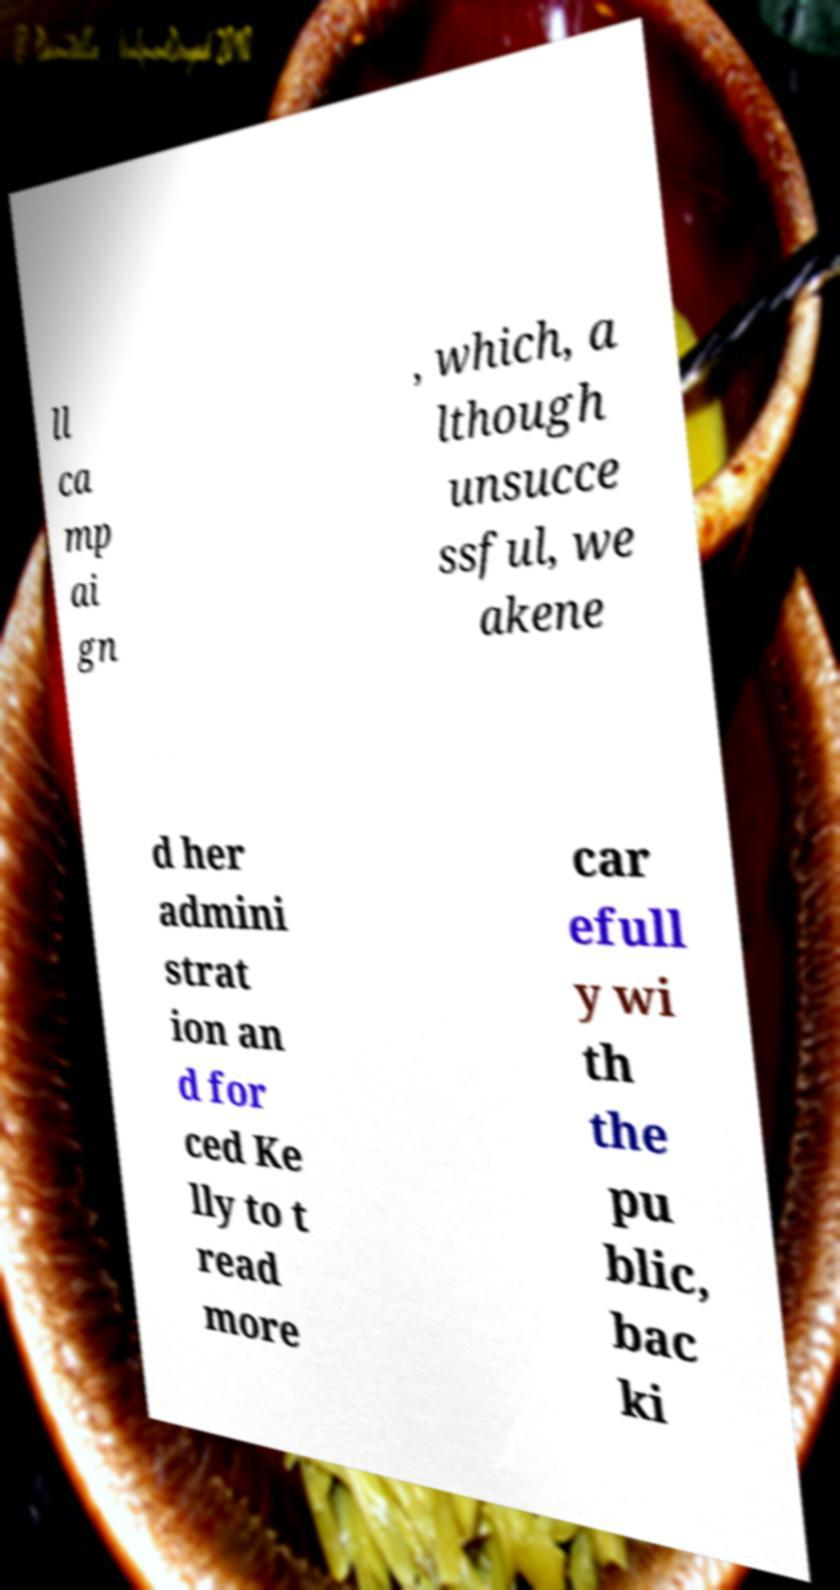What messages or text are displayed in this image? I need them in a readable, typed format. ll ca mp ai gn , which, a lthough unsucce ssful, we akene d her admini strat ion an d for ced Ke lly to t read more car efull y wi th the pu blic, bac ki 